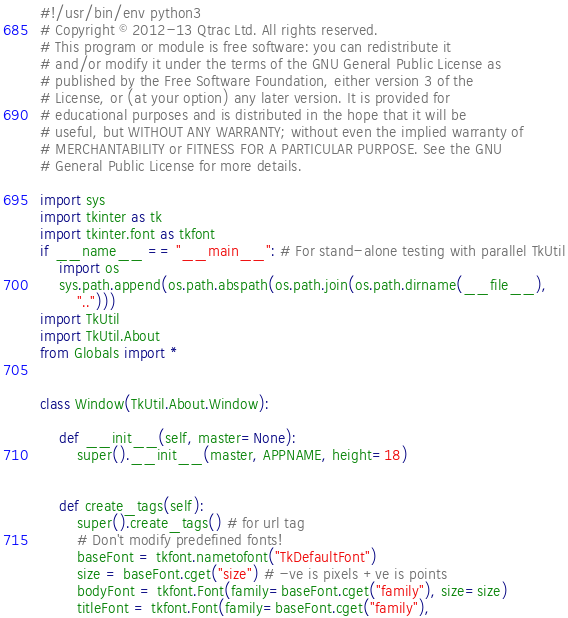<code> <loc_0><loc_0><loc_500><loc_500><_Python_>#!/usr/bin/env python3
# Copyright © 2012-13 Qtrac Ltd. All rights reserved.
# This program or module is free software: you can redistribute it
# and/or modify it under the terms of the GNU General Public License as
# published by the Free Software Foundation, either version 3 of the
# License, or (at your option) any later version. It is provided for
# educational purposes and is distributed in the hope that it will be
# useful, but WITHOUT ANY WARRANTY; without even the implied warranty of
# MERCHANTABILITY or FITNESS FOR A PARTICULAR PURPOSE. See the GNU
# General Public License for more details.

import sys
import tkinter as tk
import tkinter.font as tkfont
if __name__ == "__main__": # For stand-alone testing with parallel TkUtil
    import os
    sys.path.append(os.path.abspath(os.path.join(os.path.dirname(__file__),
        "..")))
import TkUtil
import TkUtil.About
from Globals import *


class Window(TkUtil.About.Window):

    def __init__(self, master=None):
        super().__init__(master, APPNAME, height=18)
            

    def create_tags(self):
        super().create_tags() # for url tag
        # Don't modify predefined fonts!
        baseFont = tkfont.nametofont("TkDefaultFont")
        size = baseFont.cget("size") # -ve is pixels +ve is points
        bodyFont = tkfont.Font(family=baseFont.cget("family"), size=size)
        titleFont = tkfont.Font(family=baseFont.cget("family"),</code> 